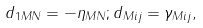<formula> <loc_0><loc_0><loc_500><loc_500>d _ { 1 M N } = - \eta _ { M N } ; d _ { M i j } = \gamma _ { M i j } ,</formula> 